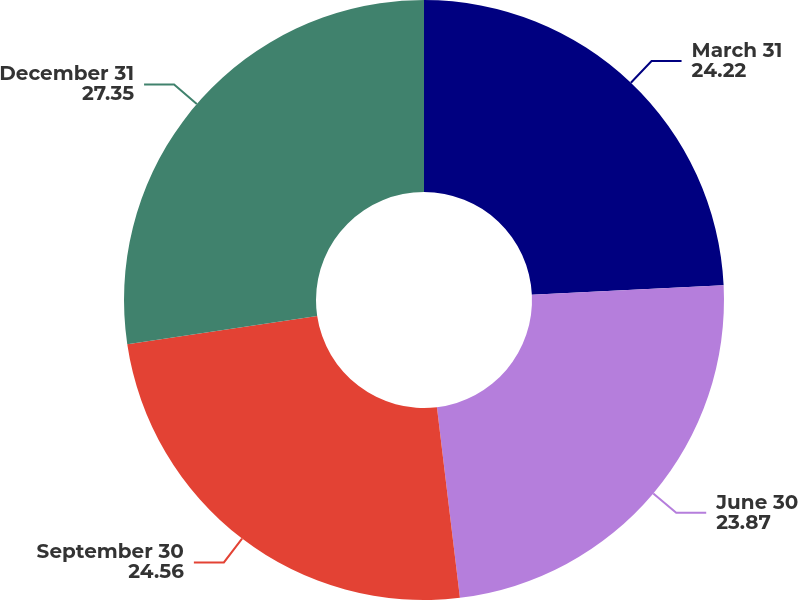Convert chart. <chart><loc_0><loc_0><loc_500><loc_500><pie_chart><fcel>March 31<fcel>June 30<fcel>September 30<fcel>December 31<nl><fcel>24.22%<fcel>23.87%<fcel>24.56%<fcel>27.35%<nl></chart> 